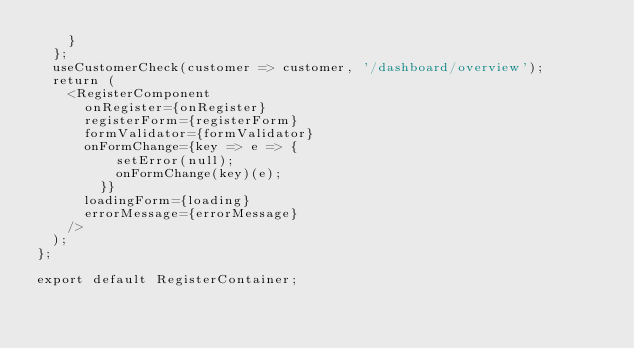Convert code to text. <code><loc_0><loc_0><loc_500><loc_500><_JavaScript_>    }
  };
  useCustomerCheck(customer => customer, '/dashboard/overview');
  return (
    <RegisterComponent
      onRegister={onRegister}
      registerForm={registerForm}
      formValidator={formValidator}
      onFormChange={key => e => {
          setError(null);
          onFormChange(key)(e);
        }}
      loadingForm={loading}
      errorMessage={errorMessage}
    />
  );
};

export default RegisterContainer;
</code> 